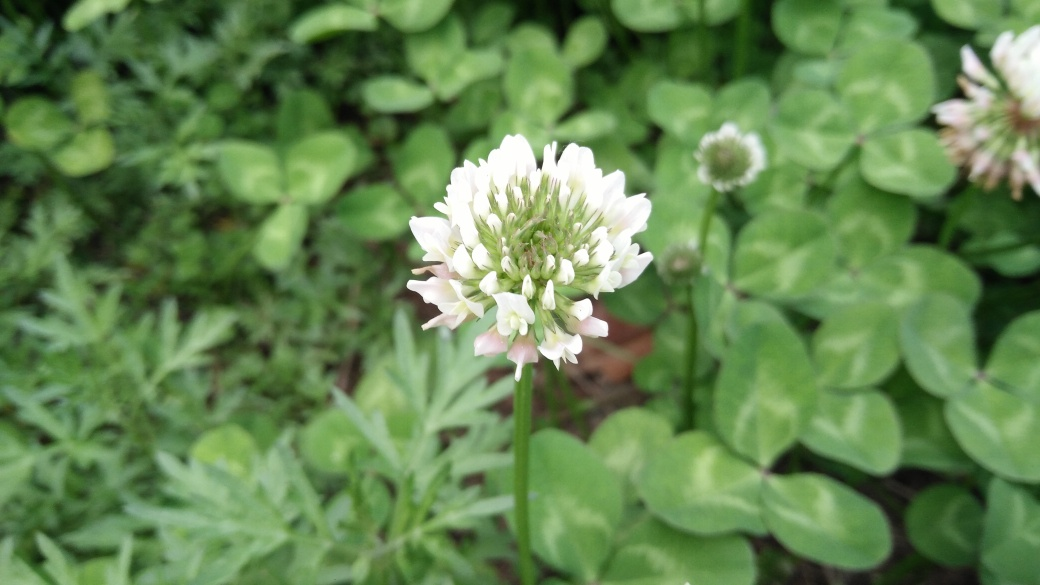Are the green leaves sharp?
A. No
B. Yes
Answer with the option's letter from the given choices directly.
 A. 